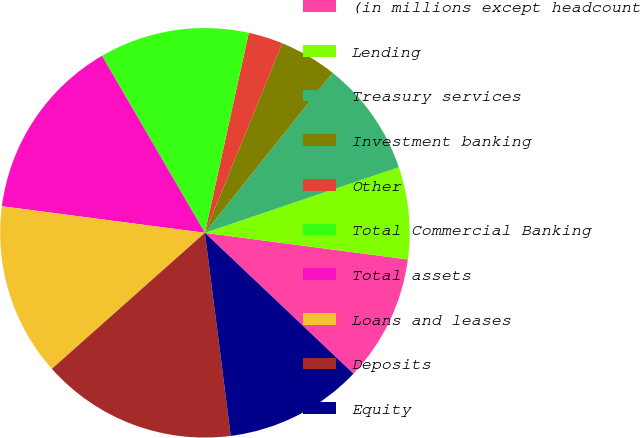<chart> <loc_0><loc_0><loc_500><loc_500><pie_chart><fcel>(in millions except headcount<fcel>Lending<fcel>Treasury services<fcel>Investment banking<fcel>Other<fcel>Total Commercial Banking<fcel>Total assets<fcel>Loans and leases<fcel>Deposits<fcel>Equity<nl><fcel>10.0%<fcel>7.27%<fcel>9.09%<fcel>4.55%<fcel>2.73%<fcel>11.82%<fcel>14.55%<fcel>13.64%<fcel>15.45%<fcel>10.91%<nl></chart> 